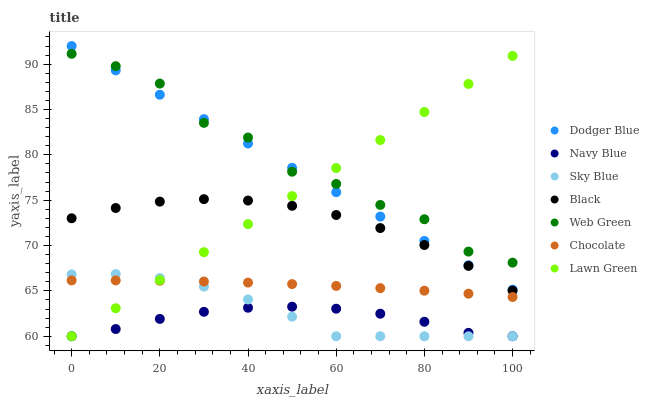Does Navy Blue have the minimum area under the curve?
Answer yes or no. Yes. Does Web Green have the maximum area under the curve?
Answer yes or no. Yes. Does Web Green have the minimum area under the curve?
Answer yes or no. No. Does Navy Blue have the maximum area under the curve?
Answer yes or no. No. Is Lawn Green the smoothest?
Answer yes or no. Yes. Is Web Green the roughest?
Answer yes or no. Yes. Is Navy Blue the smoothest?
Answer yes or no. No. Is Navy Blue the roughest?
Answer yes or no. No. Does Lawn Green have the lowest value?
Answer yes or no. Yes. Does Web Green have the lowest value?
Answer yes or no. No. Does Dodger Blue have the highest value?
Answer yes or no. Yes. Does Web Green have the highest value?
Answer yes or no. No. Is Sky Blue less than Web Green?
Answer yes or no. Yes. Is Web Green greater than Sky Blue?
Answer yes or no. Yes. Does Lawn Green intersect Sky Blue?
Answer yes or no. Yes. Is Lawn Green less than Sky Blue?
Answer yes or no. No. Is Lawn Green greater than Sky Blue?
Answer yes or no. No. Does Sky Blue intersect Web Green?
Answer yes or no. No. 